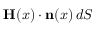<formula> <loc_0><loc_0><loc_500><loc_500>H ( x ) \cdot n ( x ) \, d S</formula> 